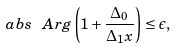<formula> <loc_0><loc_0><loc_500><loc_500>\ a b s { \ A r g \left ( 1 + \frac { \Delta _ { 0 } } { \Delta _ { 1 } x } \right ) } \leq \epsilon ,</formula> 